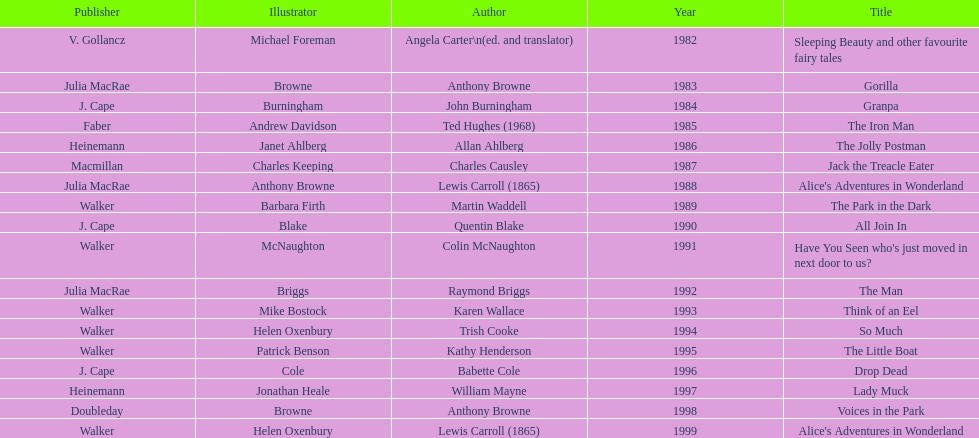What is the only title listed for 1999? Alice's Adventures in Wonderland. 